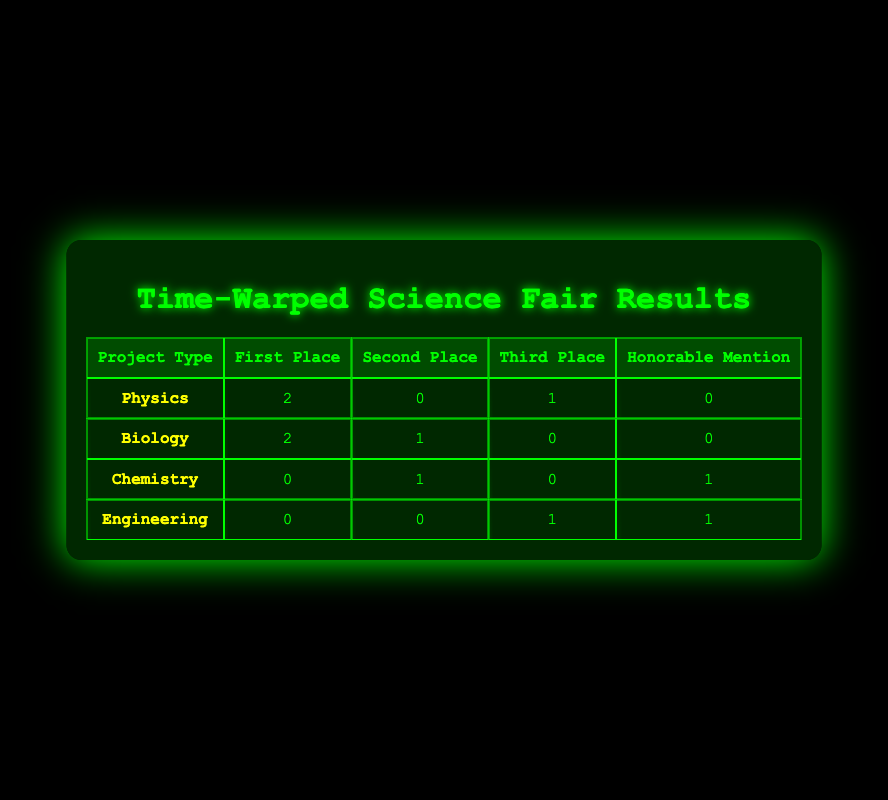What's the total number of first place awards in Biology? There are two first place awards listed under the Biology project type, awarded to Fiona Zhang and Julia Chen.
Answer: 2 How many students received an Honorable Mention in Engineering? There is one Honorable Mention in Engineering provided in the table, awarded to Hannah Lee.
Answer: 1 What is the difference in the number of second place awards between Chemistry and Biology? Biology has one second place award (George Patel), while Chemistry has one as well (Brian Garcia), resulting in no difference (1 - 1 = 0).
Answer: 0 Is it true that no projects in Chemistry received a First Place award? Yes, according to the data in the table, Chemistry received zero first place awards.
Answer: Yes Which project type received the highest number of awards in total? By summing the total awards (first, second, third, and honorable mention) for each project type: Physics (3), Biology (3), Chemistry (2), and Engineering (2). Physics and Biology are tied with 3 awards each, so they receive the highest number of awards.
Answer: Physics and Biology How many awards did Physics receive compared to Engineering? Physics received a total of 3 awards (2 first + 0 second + 1 third + 0 honorable mention), while Engineering received 2 awards (0 first + 0 second + 1 third + 1 honorable mention). The difference is 3 - 2 = 1 award more in Physics.
Answer: 1 more in Physics How many more students received awards in Physics than in Chemistry? Physics had a total of 3 awards (2 first, 0 second, 1 third) and Chemistry had a total of 2 awards (0 first, 1 second, 1 honorable mention). Hence, Physics has 3 - 2 = 1 more award than Chemistry.
Answer: 1 more Which project type has received no First Place awards? From the table, neither Chemistry nor Engineering has received any First Place awards (0 values in the first place column).
Answer: Chemistry and Engineering 